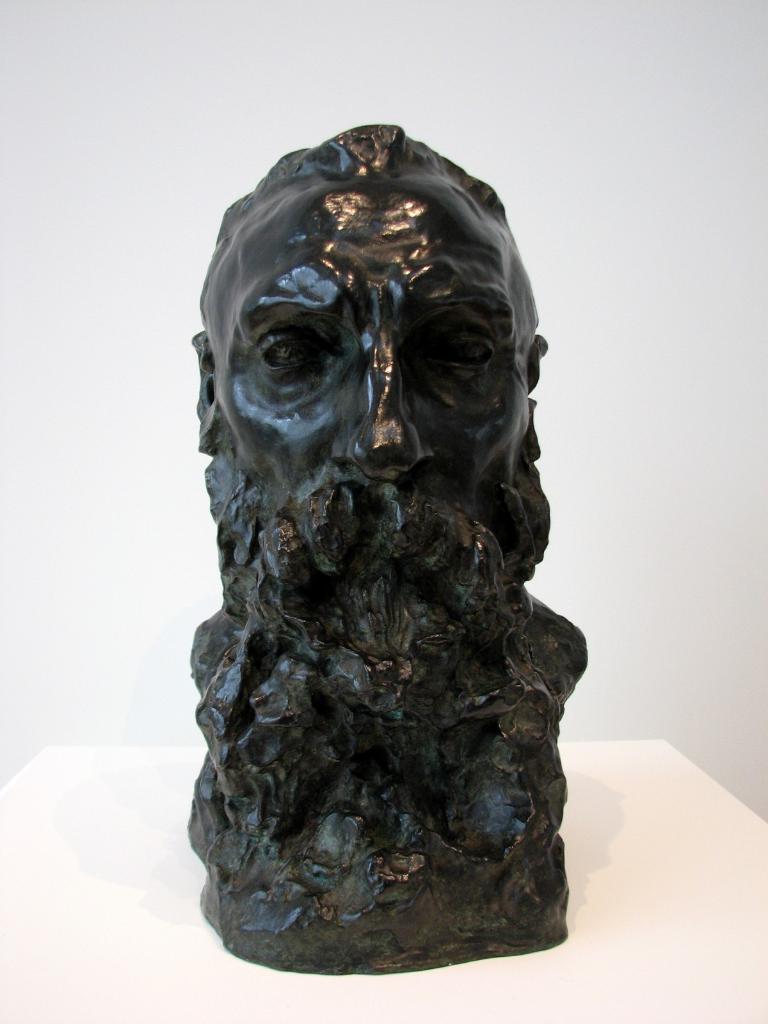In one or two sentences, can you explain what this image depicts? In the center of the image, we can see a sculpture on the table and in the background, there is a wall. 